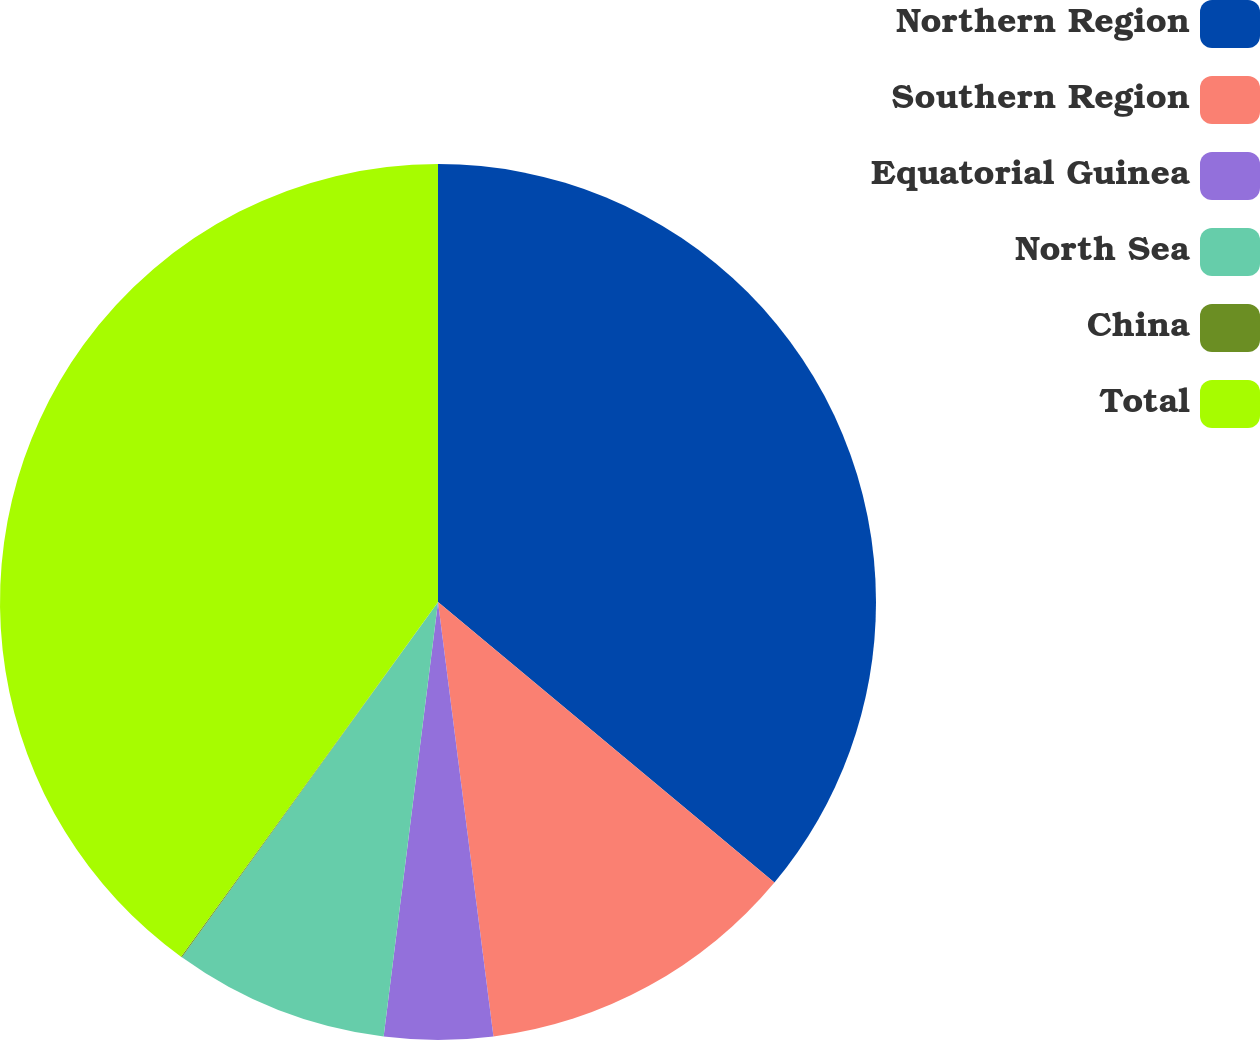Convert chart to OTSL. <chart><loc_0><loc_0><loc_500><loc_500><pie_chart><fcel>Northern Region<fcel>Southern Region<fcel>Equatorial Guinea<fcel>North Sea<fcel>China<fcel>Total<nl><fcel>36.06%<fcel>11.92%<fcel>4.0%<fcel>7.96%<fcel>0.04%<fcel>40.02%<nl></chart> 